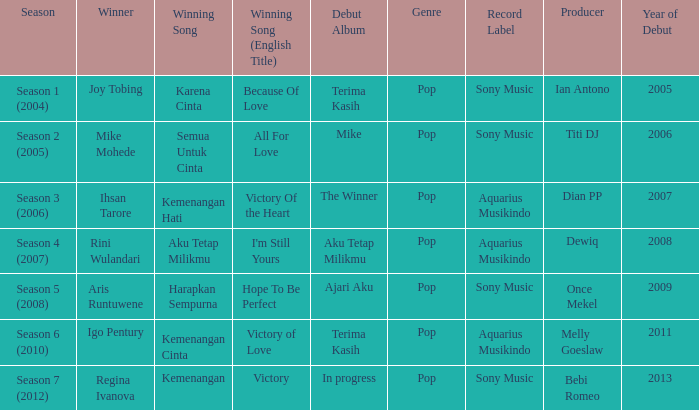Which album debuted in season 2 (2005)? Mike. 